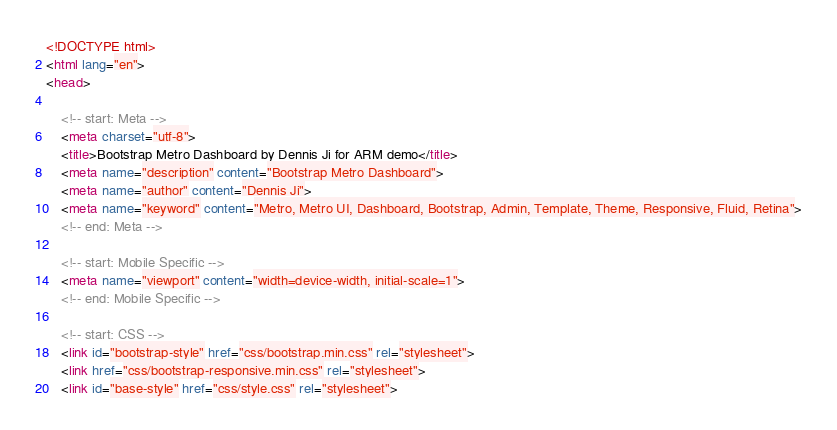Convert code to text. <code><loc_0><loc_0><loc_500><loc_500><_HTML_><!DOCTYPE html>
<html lang="en">
<head>
	
	<!-- start: Meta -->
	<meta charset="utf-8">
	<title>Bootstrap Metro Dashboard by Dennis Ji for ARM demo</title>
	<meta name="description" content="Bootstrap Metro Dashboard">
	<meta name="author" content="Dennis Ji">
	<meta name="keyword" content="Metro, Metro UI, Dashboard, Bootstrap, Admin, Template, Theme, Responsive, Fluid, Retina">
	<!-- end: Meta -->
	
	<!-- start: Mobile Specific -->
	<meta name="viewport" content="width=device-width, initial-scale=1">
	<!-- end: Mobile Specific -->
	
	<!-- start: CSS -->
	<link id="bootstrap-style" href="css/bootstrap.min.css" rel="stylesheet">
	<link href="css/bootstrap-responsive.min.css" rel="stylesheet">
	<link id="base-style" href="css/style.css" rel="stylesheet"></code> 